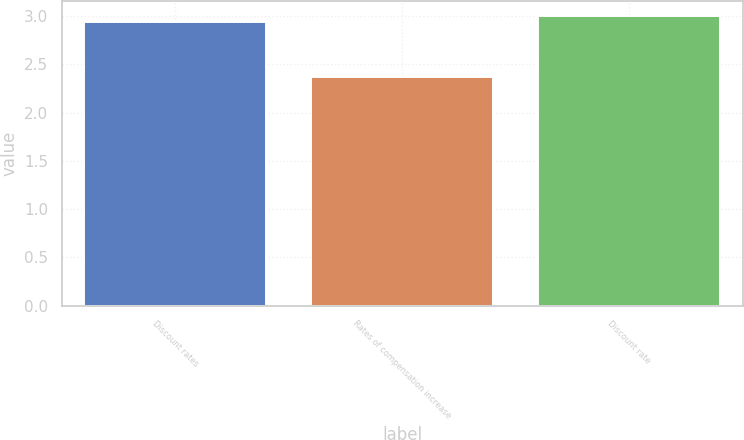Convert chart to OTSL. <chart><loc_0><loc_0><loc_500><loc_500><bar_chart><fcel>Discount rates<fcel>Rates of compensation increase<fcel>Discount rate<nl><fcel>2.94<fcel>2.37<fcel>3<nl></chart> 